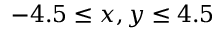Convert formula to latex. <formula><loc_0><loc_0><loc_500><loc_500>- 4 . 5 \leq x , y \leq 4 . 5</formula> 